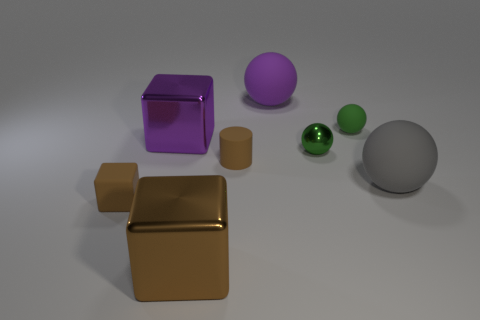Add 1 brown matte cylinders. How many objects exist? 9 Subtract all cylinders. How many objects are left? 7 Add 8 brown matte cubes. How many brown matte cubes are left? 9 Add 2 small red shiny cubes. How many small red shiny cubes exist? 2 Subtract 0 yellow cubes. How many objects are left? 8 Subtract all green blocks. Subtract all purple shiny things. How many objects are left? 7 